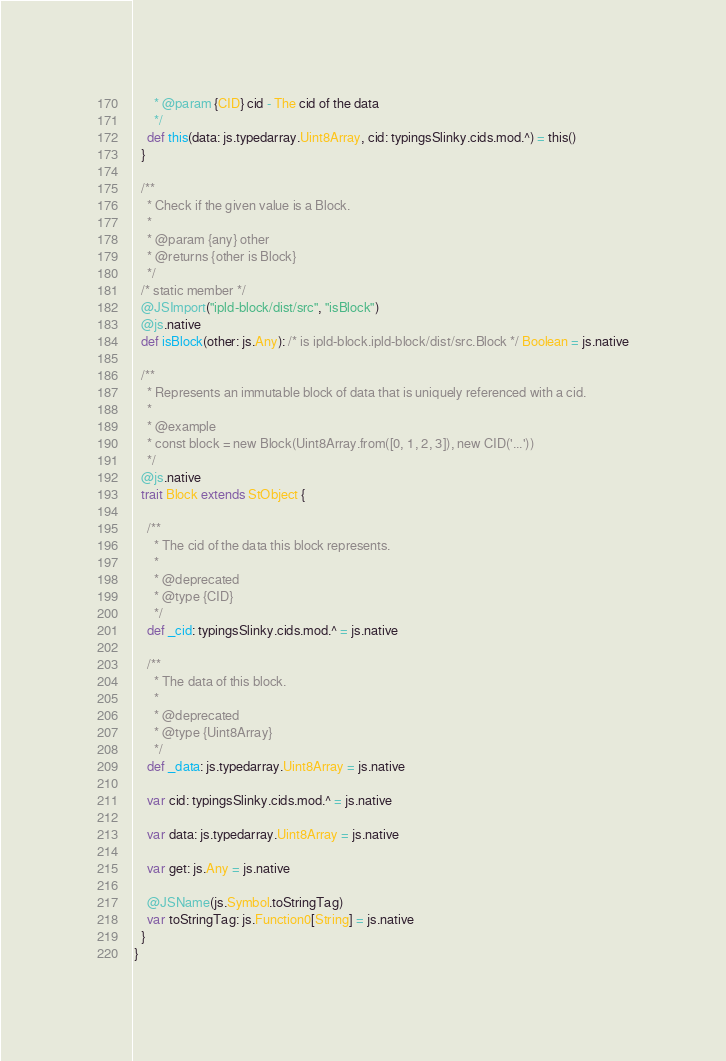Convert code to text. <code><loc_0><loc_0><loc_500><loc_500><_Scala_>      * @param {CID} cid - The cid of the data
      */
    def this(data: js.typedarray.Uint8Array, cid: typingsSlinky.cids.mod.^) = this()
  }
  
  /**
    * Check if the given value is a Block.
    *
    * @param {any} other
    * @returns {other is Block}
    */
  /* static member */
  @JSImport("ipld-block/dist/src", "isBlock")
  @js.native
  def isBlock(other: js.Any): /* is ipld-block.ipld-block/dist/src.Block */ Boolean = js.native
  
  /**
    * Represents an immutable block of data that is uniquely referenced with a cid.
    *
    * @example
    * const block = new Block(Uint8Array.from([0, 1, 2, 3]), new CID('...'))
    */
  @js.native
  trait Block extends StObject {
    
    /**
      * The cid of the data this block represents.
      *
      * @deprecated
      * @type {CID}
      */
    def _cid: typingsSlinky.cids.mod.^ = js.native
    
    /**
      * The data of this block.
      *
      * @deprecated
      * @type {Uint8Array}
      */
    def _data: js.typedarray.Uint8Array = js.native
    
    var cid: typingsSlinky.cids.mod.^ = js.native
    
    var data: js.typedarray.Uint8Array = js.native
    
    var get: js.Any = js.native
    
    @JSName(js.Symbol.toStringTag)
    var toStringTag: js.Function0[String] = js.native
  }
}
</code> 